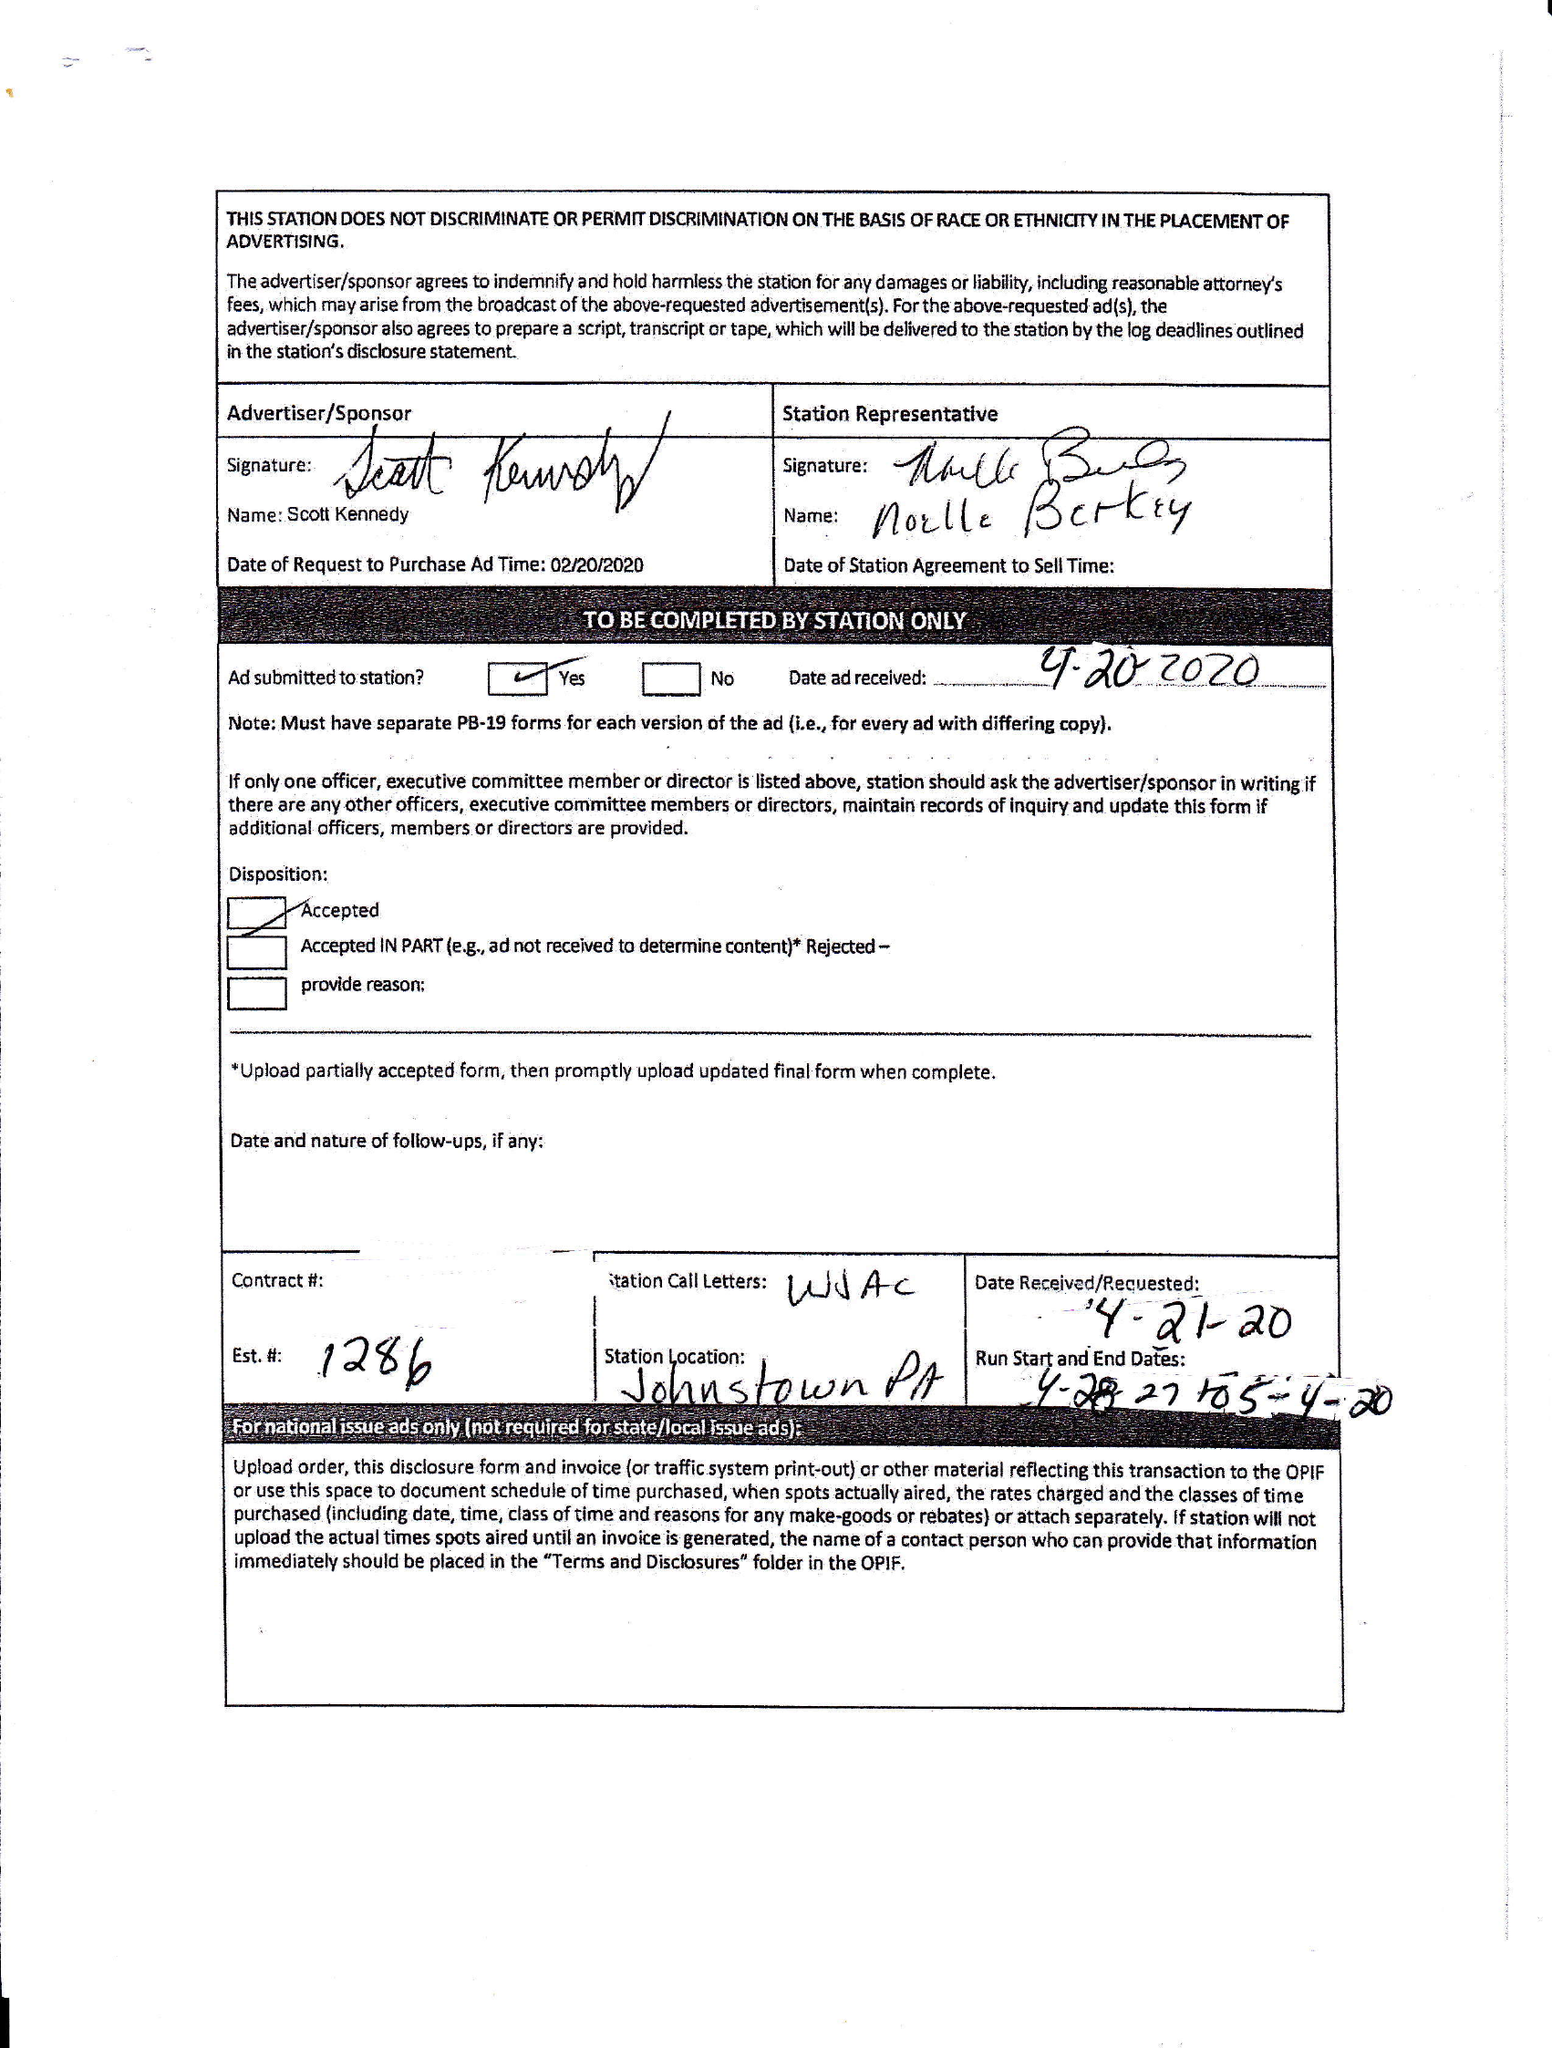What is the value for the contract_num?
Answer the question using a single word or phrase. None 